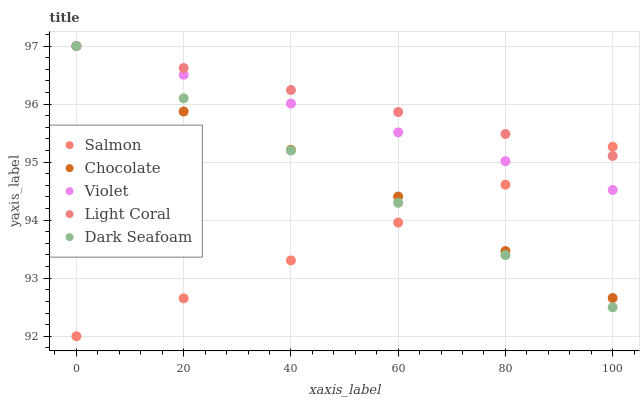Does Salmon have the minimum area under the curve?
Answer yes or no. Yes. Does Light Coral have the maximum area under the curve?
Answer yes or no. Yes. Does Dark Seafoam have the minimum area under the curve?
Answer yes or no. No. Does Dark Seafoam have the maximum area under the curve?
Answer yes or no. No. Is Light Coral the smoothest?
Answer yes or no. Yes. Is Chocolate the roughest?
Answer yes or no. Yes. Is Dark Seafoam the smoothest?
Answer yes or no. No. Is Dark Seafoam the roughest?
Answer yes or no. No. Does Salmon have the lowest value?
Answer yes or no. Yes. Does Dark Seafoam have the lowest value?
Answer yes or no. No. Does Chocolate have the highest value?
Answer yes or no. Yes. Does Salmon have the highest value?
Answer yes or no. No. Does Light Coral intersect Violet?
Answer yes or no. Yes. Is Light Coral less than Violet?
Answer yes or no. No. Is Light Coral greater than Violet?
Answer yes or no. No. 